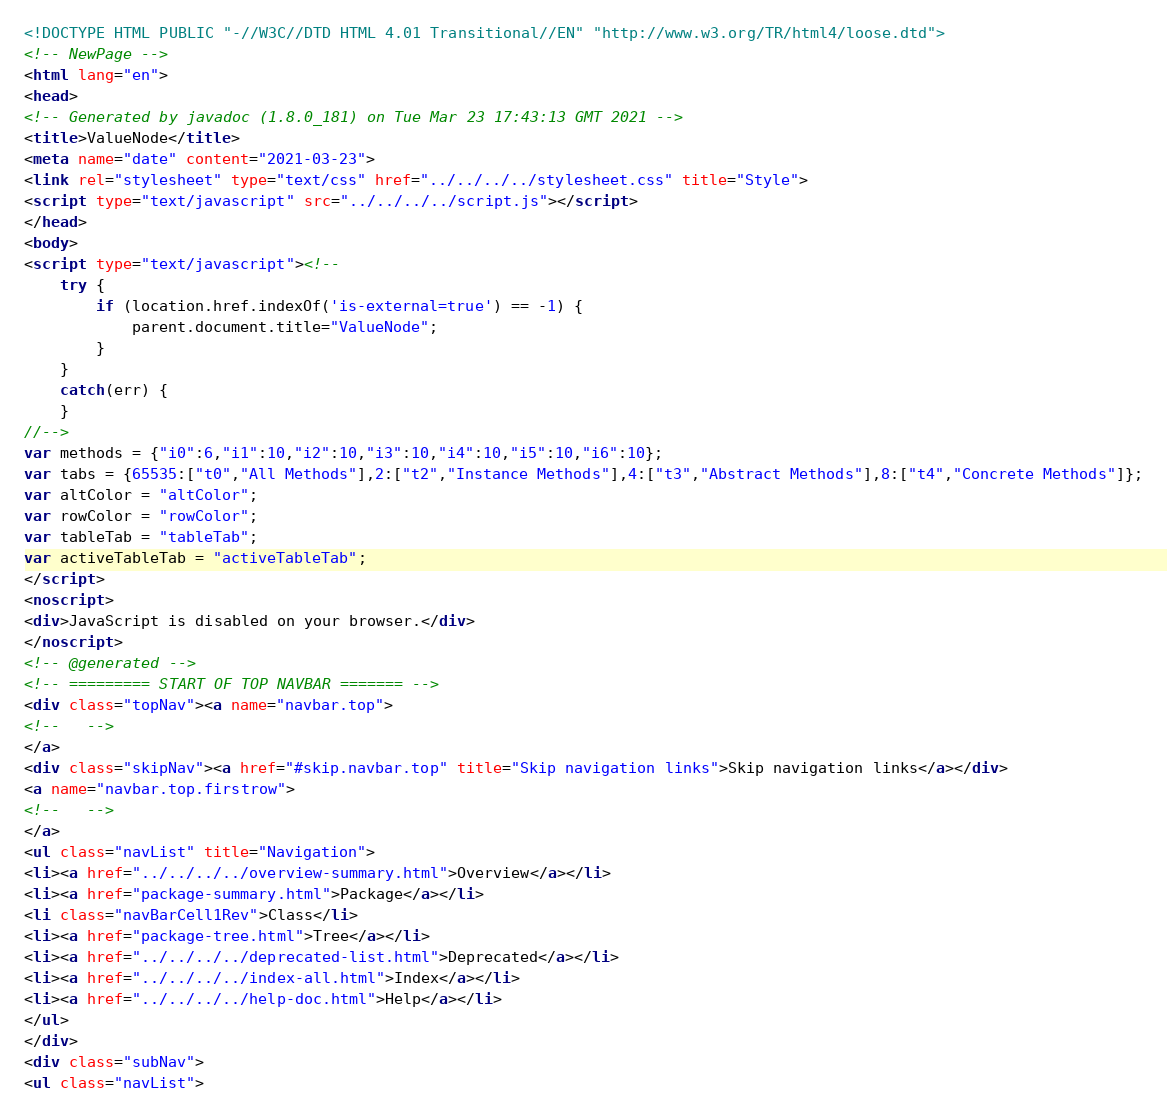<code> <loc_0><loc_0><loc_500><loc_500><_HTML_><!DOCTYPE HTML PUBLIC "-//W3C//DTD HTML 4.01 Transitional//EN" "http://www.w3.org/TR/html4/loose.dtd">
<!-- NewPage -->
<html lang="en">
<head>
<!-- Generated by javadoc (1.8.0_181) on Tue Mar 23 17:43:13 GMT 2021 -->
<title>ValueNode</title>
<meta name="date" content="2021-03-23">
<link rel="stylesheet" type="text/css" href="../../../../stylesheet.css" title="Style">
<script type="text/javascript" src="../../../../script.js"></script>
</head>
<body>
<script type="text/javascript"><!--
    try {
        if (location.href.indexOf('is-external=true') == -1) {
            parent.document.title="ValueNode";
        }
    }
    catch(err) {
    }
//-->
var methods = {"i0":6,"i1":10,"i2":10,"i3":10,"i4":10,"i5":10,"i6":10};
var tabs = {65535:["t0","All Methods"],2:["t2","Instance Methods"],4:["t3","Abstract Methods"],8:["t4","Concrete Methods"]};
var altColor = "altColor";
var rowColor = "rowColor";
var tableTab = "tableTab";
var activeTableTab = "activeTableTab";
</script>
<noscript>
<div>JavaScript is disabled on your browser.</div>
</noscript>
<!-- @generated -->
<!-- ========= START OF TOP NAVBAR ======= -->
<div class="topNav"><a name="navbar.top">
<!--   -->
</a>
<div class="skipNav"><a href="#skip.navbar.top" title="Skip navigation links">Skip navigation links</a></div>
<a name="navbar.top.firstrow">
<!--   -->
</a>
<ul class="navList" title="Navigation">
<li><a href="../../../../overview-summary.html">Overview</a></li>
<li><a href="package-summary.html">Package</a></li>
<li class="navBarCell1Rev">Class</li>
<li><a href="package-tree.html">Tree</a></li>
<li><a href="../../../../deprecated-list.html">Deprecated</a></li>
<li><a href="../../../../index-all.html">Index</a></li>
<li><a href="../../../../help-doc.html">Help</a></li>
</ul>
</div>
<div class="subNav">
<ul class="navList"></code> 